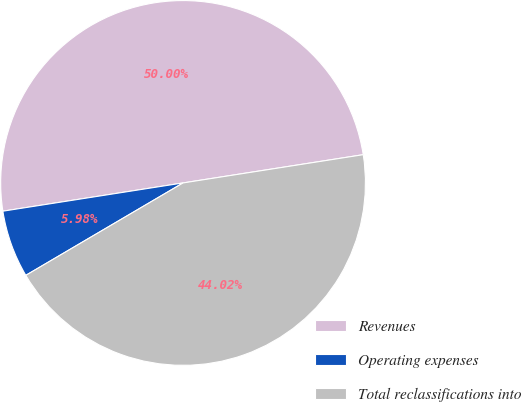Convert chart. <chart><loc_0><loc_0><loc_500><loc_500><pie_chart><fcel>Revenues<fcel>Operating expenses<fcel>Total reclassifications into<nl><fcel>50.0%<fcel>5.98%<fcel>44.02%<nl></chart> 